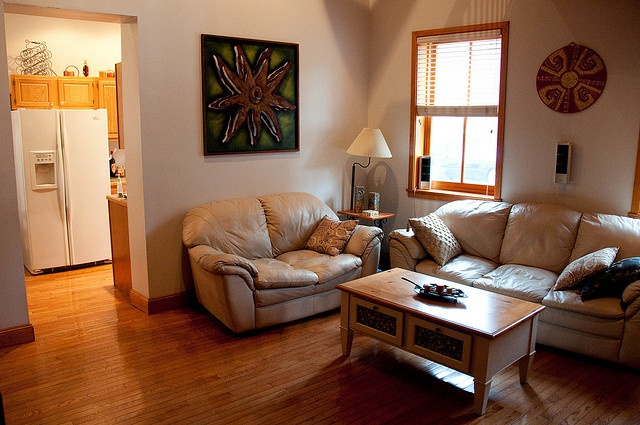Describe the objects in this image and their specific colors. I can see couch in gray, black, maroon, and white tones, couch in gray, maroon, and tan tones, and refrigerator in gray, tan, and beige tones in this image. 